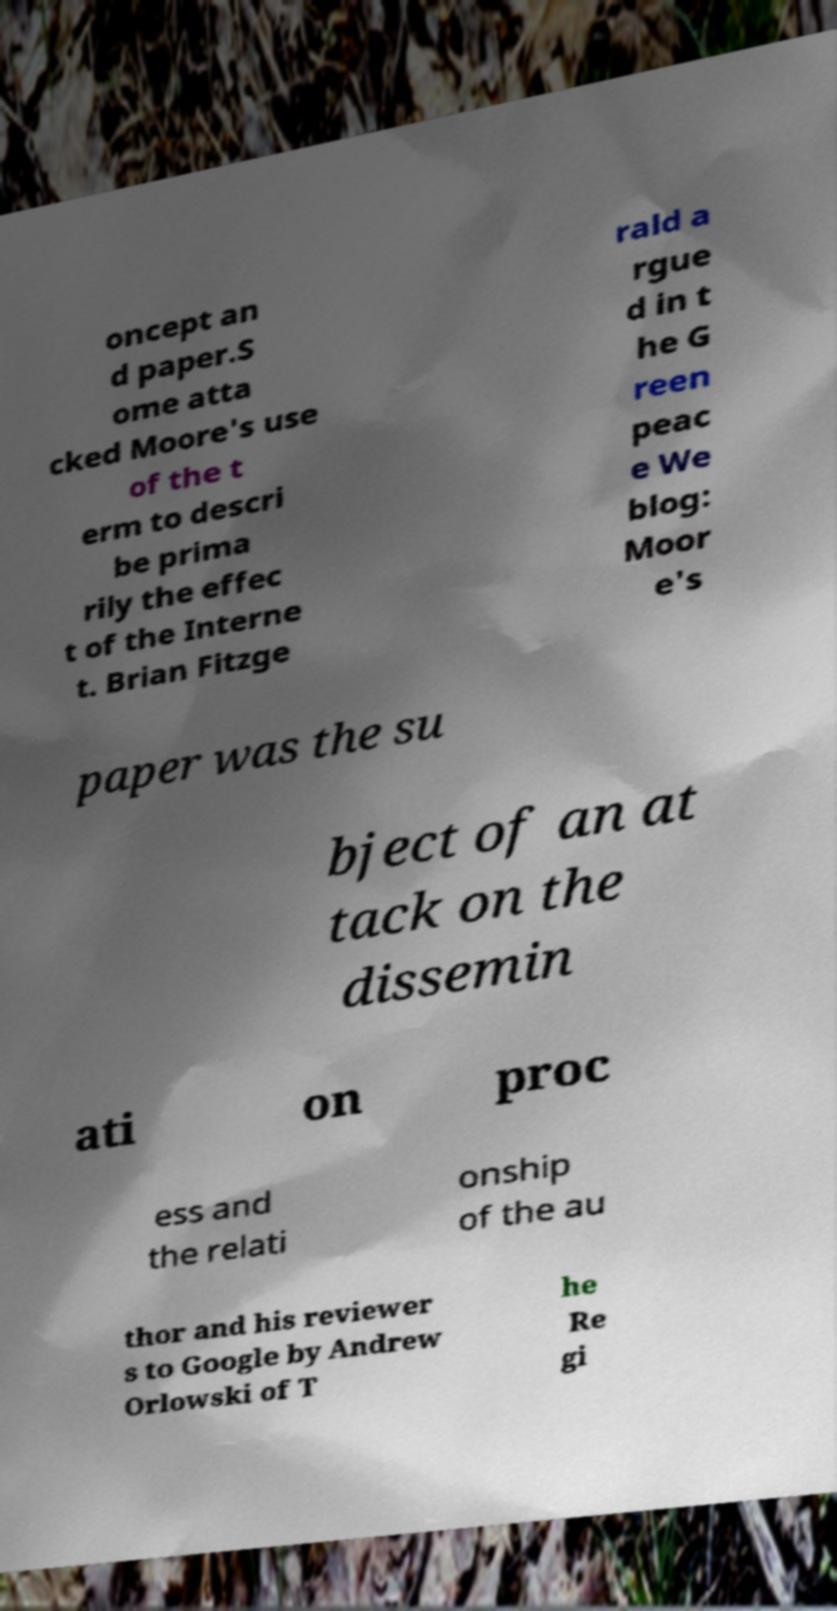Please identify and transcribe the text found in this image. oncept an d paper.S ome atta cked Moore's use of the t erm to descri be prima rily the effec t of the Interne t. Brian Fitzge rald a rgue d in t he G reen peac e We blog: Moor e's paper was the su bject of an at tack on the dissemin ati on proc ess and the relati onship of the au thor and his reviewer s to Google by Andrew Orlowski of T he Re gi 